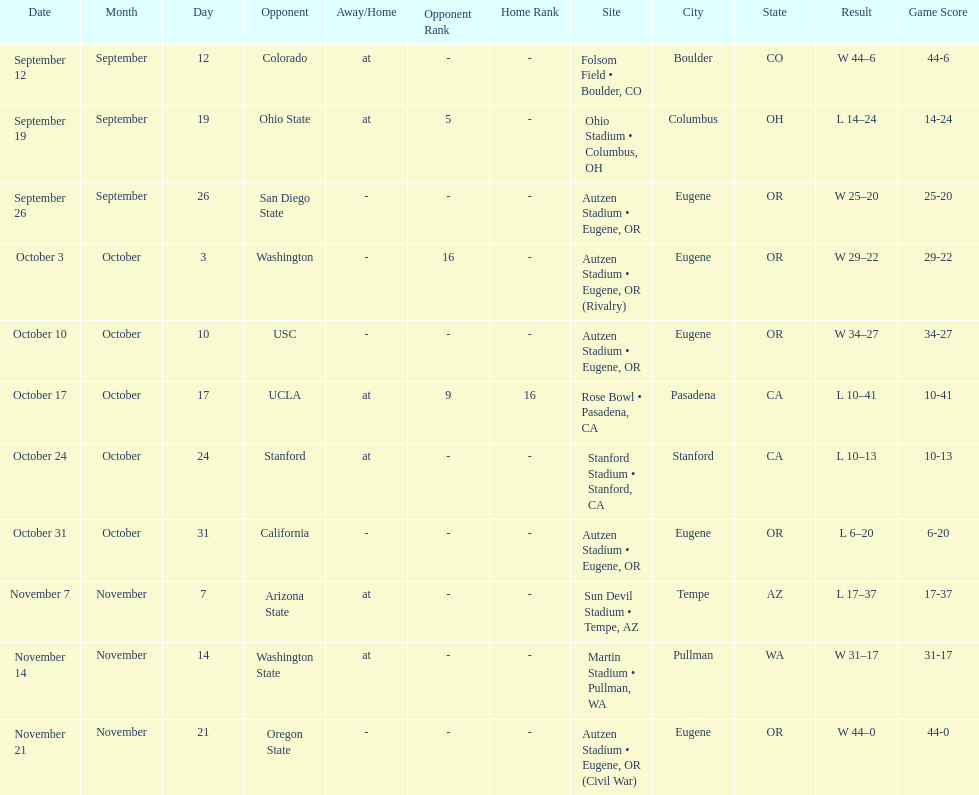Did the team win or lose more games? Win. 